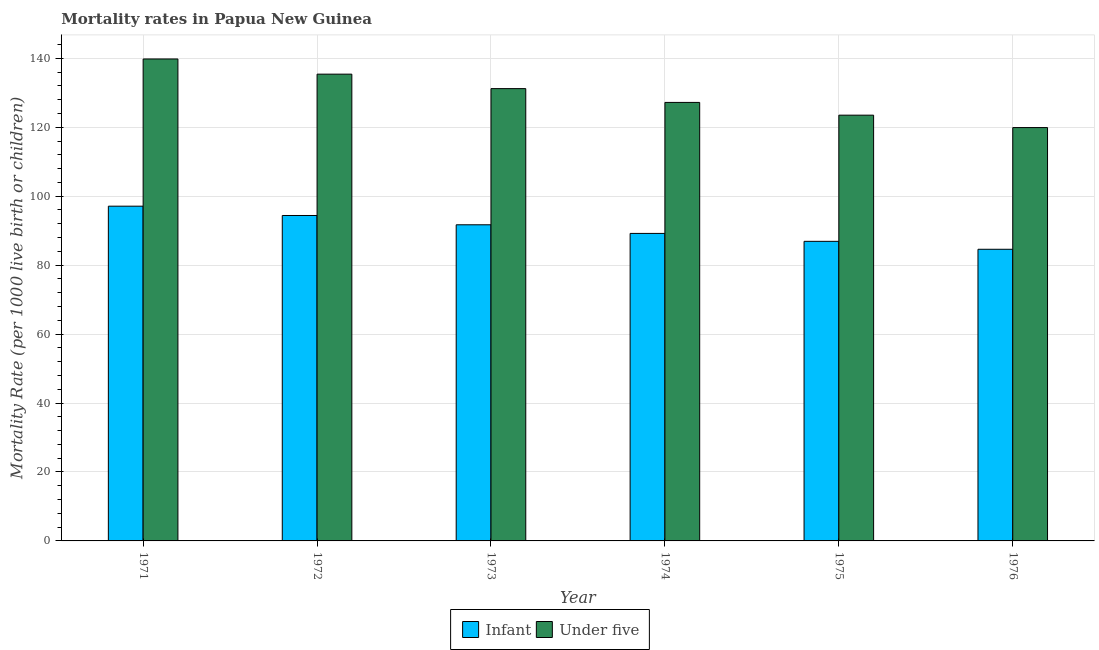How many different coloured bars are there?
Keep it short and to the point. 2. How many groups of bars are there?
Your answer should be compact. 6. What is the label of the 5th group of bars from the left?
Ensure brevity in your answer.  1975. What is the under-5 mortality rate in 1974?
Your response must be concise. 127.2. Across all years, what is the maximum infant mortality rate?
Offer a very short reply. 97.1. Across all years, what is the minimum infant mortality rate?
Make the answer very short. 84.6. In which year was the under-5 mortality rate maximum?
Give a very brief answer. 1971. In which year was the under-5 mortality rate minimum?
Make the answer very short. 1976. What is the total infant mortality rate in the graph?
Your answer should be compact. 543.9. What is the difference between the infant mortality rate in 1971 and that in 1974?
Offer a terse response. 7.9. What is the difference between the under-5 mortality rate in 1974 and the infant mortality rate in 1972?
Ensure brevity in your answer.  -8.2. What is the average infant mortality rate per year?
Provide a short and direct response. 90.65. In how many years, is the infant mortality rate greater than 112?
Make the answer very short. 0. What is the ratio of the infant mortality rate in 1972 to that in 1974?
Your response must be concise. 1.06. What is the difference between the highest and the second highest infant mortality rate?
Offer a very short reply. 2.7. Is the sum of the under-5 mortality rate in 1972 and 1976 greater than the maximum infant mortality rate across all years?
Your answer should be compact. Yes. What does the 2nd bar from the left in 1972 represents?
Offer a very short reply. Under five. What does the 2nd bar from the right in 1973 represents?
Provide a short and direct response. Infant. How many bars are there?
Offer a terse response. 12. Are all the bars in the graph horizontal?
Make the answer very short. No. Are the values on the major ticks of Y-axis written in scientific E-notation?
Ensure brevity in your answer.  No. Does the graph contain grids?
Offer a terse response. Yes. Where does the legend appear in the graph?
Your response must be concise. Bottom center. How many legend labels are there?
Offer a terse response. 2. What is the title of the graph?
Keep it short and to the point. Mortality rates in Papua New Guinea. What is the label or title of the X-axis?
Provide a succinct answer. Year. What is the label or title of the Y-axis?
Provide a succinct answer. Mortality Rate (per 1000 live birth or children). What is the Mortality Rate (per 1000 live birth or children) of Infant in 1971?
Provide a short and direct response. 97.1. What is the Mortality Rate (per 1000 live birth or children) in Under five in 1971?
Ensure brevity in your answer.  139.8. What is the Mortality Rate (per 1000 live birth or children) in Infant in 1972?
Provide a succinct answer. 94.4. What is the Mortality Rate (per 1000 live birth or children) in Under five in 1972?
Ensure brevity in your answer.  135.4. What is the Mortality Rate (per 1000 live birth or children) in Infant in 1973?
Offer a very short reply. 91.7. What is the Mortality Rate (per 1000 live birth or children) in Under five in 1973?
Your answer should be compact. 131.2. What is the Mortality Rate (per 1000 live birth or children) in Infant in 1974?
Offer a very short reply. 89.2. What is the Mortality Rate (per 1000 live birth or children) in Under five in 1974?
Offer a terse response. 127.2. What is the Mortality Rate (per 1000 live birth or children) of Infant in 1975?
Your answer should be very brief. 86.9. What is the Mortality Rate (per 1000 live birth or children) of Under five in 1975?
Provide a succinct answer. 123.5. What is the Mortality Rate (per 1000 live birth or children) in Infant in 1976?
Your answer should be very brief. 84.6. What is the Mortality Rate (per 1000 live birth or children) of Under five in 1976?
Your response must be concise. 119.9. Across all years, what is the maximum Mortality Rate (per 1000 live birth or children) of Infant?
Make the answer very short. 97.1. Across all years, what is the maximum Mortality Rate (per 1000 live birth or children) in Under five?
Ensure brevity in your answer.  139.8. Across all years, what is the minimum Mortality Rate (per 1000 live birth or children) in Infant?
Offer a very short reply. 84.6. Across all years, what is the minimum Mortality Rate (per 1000 live birth or children) of Under five?
Ensure brevity in your answer.  119.9. What is the total Mortality Rate (per 1000 live birth or children) of Infant in the graph?
Your response must be concise. 543.9. What is the total Mortality Rate (per 1000 live birth or children) of Under five in the graph?
Your response must be concise. 777. What is the difference between the Mortality Rate (per 1000 live birth or children) in Under five in 1971 and that in 1972?
Provide a short and direct response. 4.4. What is the difference between the Mortality Rate (per 1000 live birth or children) of Under five in 1971 and that in 1973?
Ensure brevity in your answer.  8.6. What is the difference between the Mortality Rate (per 1000 live birth or children) in Infant in 1971 and that in 1974?
Give a very brief answer. 7.9. What is the difference between the Mortality Rate (per 1000 live birth or children) of Under five in 1971 and that in 1974?
Provide a succinct answer. 12.6. What is the difference between the Mortality Rate (per 1000 live birth or children) in Under five in 1971 and that in 1975?
Keep it short and to the point. 16.3. What is the difference between the Mortality Rate (per 1000 live birth or children) in Infant in 1971 and that in 1976?
Give a very brief answer. 12.5. What is the difference between the Mortality Rate (per 1000 live birth or children) in Under five in 1971 and that in 1976?
Your answer should be compact. 19.9. What is the difference between the Mortality Rate (per 1000 live birth or children) of Infant in 1972 and that in 1973?
Provide a short and direct response. 2.7. What is the difference between the Mortality Rate (per 1000 live birth or children) in Under five in 1972 and that in 1975?
Your answer should be very brief. 11.9. What is the difference between the Mortality Rate (per 1000 live birth or children) in Under five in 1972 and that in 1976?
Provide a succinct answer. 15.5. What is the difference between the Mortality Rate (per 1000 live birth or children) in Infant in 1973 and that in 1974?
Ensure brevity in your answer.  2.5. What is the difference between the Mortality Rate (per 1000 live birth or children) of Under five in 1973 and that in 1974?
Offer a terse response. 4. What is the difference between the Mortality Rate (per 1000 live birth or children) in Infant in 1973 and that in 1976?
Provide a succinct answer. 7.1. What is the difference between the Mortality Rate (per 1000 live birth or children) of Under five in 1973 and that in 1976?
Your answer should be very brief. 11.3. What is the difference between the Mortality Rate (per 1000 live birth or children) in Under five in 1974 and that in 1975?
Your response must be concise. 3.7. What is the difference between the Mortality Rate (per 1000 live birth or children) of Under five in 1974 and that in 1976?
Ensure brevity in your answer.  7.3. What is the difference between the Mortality Rate (per 1000 live birth or children) in Under five in 1975 and that in 1976?
Provide a short and direct response. 3.6. What is the difference between the Mortality Rate (per 1000 live birth or children) of Infant in 1971 and the Mortality Rate (per 1000 live birth or children) of Under five in 1972?
Your answer should be very brief. -38.3. What is the difference between the Mortality Rate (per 1000 live birth or children) of Infant in 1971 and the Mortality Rate (per 1000 live birth or children) of Under five in 1973?
Your answer should be very brief. -34.1. What is the difference between the Mortality Rate (per 1000 live birth or children) in Infant in 1971 and the Mortality Rate (per 1000 live birth or children) in Under five in 1974?
Offer a very short reply. -30.1. What is the difference between the Mortality Rate (per 1000 live birth or children) in Infant in 1971 and the Mortality Rate (per 1000 live birth or children) in Under five in 1975?
Your answer should be very brief. -26.4. What is the difference between the Mortality Rate (per 1000 live birth or children) of Infant in 1971 and the Mortality Rate (per 1000 live birth or children) of Under five in 1976?
Make the answer very short. -22.8. What is the difference between the Mortality Rate (per 1000 live birth or children) in Infant in 1972 and the Mortality Rate (per 1000 live birth or children) in Under five in 1973?
Make the answer very short. -36.8. What is the difference between the Mortality Rate (per 1000 live birth or children) of Infant in 1972 and the Mortality Rate (per 1000 live birth or children) of Under five in 1974?
Your answer should be compact. -32.8. What is the difference between the Mortality Rate (per 1000 live birth or children) in Infant in 1972 and the Mortality Rate (per 1000 live birth or children) in Under five in 1975?
Your answer should be compact. -29.1. What is the difference between the Mortality Rate (per 1000 live birth or children) in Infant in 1972 and the Mortality Rate (per 1000 live birth or children) in Under five in 1976?
Your answer should be very brief. -25.5. What is the difference between the Mortality Rate (per 1000 live birth or children) in Infant in 1973 and the Mortality Rate (per 1000 live birth or children) in Under five in 1974?
Keep it short and to the point. -35.5. What is the difference between the Mortality Rate (per 1000 live birth or children) of Infant in 1973 and the Mortality Rate (per 1000 live birth or children) of Under five in 1975?
Give a very brief answer. -31.8. What is the difference between the Mortality Rate (per 1000 live birth or children) of Infant in 1973 and the Mortality Rate (per 1000 live birth or children) of Under five in 1976?
Your answer should be compact. -28.2. What is the difference between the Mortality Rate (per 1000 live birth or children) of Infant in 1974 and the Mortality Rate (per 1000 live birth or children) of Under five in 1975?
Provide a succinct answer. -34.3. What is the difference between the Mortality Rate (per 1000 live birth or children) in Infant in 1974 and the Mortality Rate (per 1000 live birth or children) in Under five in 1976?
Make the answer very short. -30.7. What is the difference between the Mortality Rate (per 1000 live birth or children) of Infant in 1975 and the Mortality Rate (per 1000 live birth or children) of Under five in 1976?
Offer a very short reply. -33. What is the average Mortality Rate (per 1000 live birth or children) in Infant per year?
Keep it short and to the point. 90.65. What is the average Mortality Rate (per 1000 live birth or children) in Under five per year?
Provide a succinct answer. 129.5. In the year 1971, what is the difference between the Mortality Rate (per 1000 live birth or children) in Infant and Mortality Rate (per 1000 live birth or children) in Under five?
Give a very brief answer. -42.7. In the year 1972, what is the difference between the Mortality Rate (per 1000 live birth or children) in Infant and Mortality Rate (per 1000 live birth or children) in Under five?
Your answer should be compact. -41. In the year 1973, what is the difference between the Mortality Rate (per 1000 live birth or children) in Infant and Mortality Rate (per 1000 live birth or children) in Under five?
Provide a short and direct response. -39.5. In the year 1974, what is the difference between the Mortality Rate (per 1000 live birth or children) in Infant and Mortality Rate (per 1000 live birth or children) in Under five?
Offer a very short reply. -38. In the year 1975, what is the difference between the Mortality Rate (per 1000 live birth or children) in Infant and Mortality Rate (per 1000 live birth or children) in Under five?
Provide a short and direct response. -36.6. In the year 1976, what is the difference between the Mortality Rate (per 1000 live birth or children) of Infant and Mortality Rate (per 1000 live birth or children) of Under five?
Keep it short and to the point. -35.3. What is the ratio of the Mortality Rate (per 1000 live birth or children) of Infant in 1971 to that in 1972?
Your response must be concise. 1.03. What is the ratio of the Mortality Rate (per 1000 live birth or children) in Under five in 1971 to that in 1972?
Offer a terse response. 1.03. What is the ratio of the Mortality Rate (per 1000 live birth or children) of Infant in 1971 to that in 1973?
Offer a very short reply. 1.06. What is the ratio of the Mortality Rate (per 1000 live birth or children) in Under five in 1971 to that in 1973?
Provide a short and direct response. 1.07. What is the ratio of the Mortality Rate (per 1000 live birth or children) in Infant in 1971 to that in 1974?
Ensure brevity in your answer.  1.09. What is the ratio of the Mortality Rate (per 1000 live birth or children) in Under five in 1971 to that in 1974?
Keep it short and to the point. 1.1. What is the ratio of the Mortality Rate (per 1000 live birth or children) of Infant in 1971 to that in 1975?
Provide a short and direct response. 1.12. What is the ratio of the Mortality Rate (per 1000 live birth or children) of Under five in 1971 to that in 1975?
Ensure brevity in your answer.  1.13. What is the ratio of the Mortality Rate (per 1000 live birth or children) of Infant in 1971 to that in 1976?
Keep it short and to the point. 1.15. What is the ratio of the Mortality Rate (per 1000 live birth or children) in Under five in 1971 to that in 1976?
Make the answer very short. 1.17. What is the ratio of the Mortality Rate (per 1000 live birth or children) in Infant in 1972 to that in 1973?
Keep it short and to the point. 1.03. What is the ratio of the Mortality Rate (per 1000 live birth or children) of Under five in 1972 to that in 1973?
Give a very brief answer. 1.03. What is the ratio of the Mortality Rate (per 1000 live birth or children) in Infant in 1972 to that in 1974?
Provide a succinct answer. 1.06. What is the ratio of the Mortality Rate (per 1000 live birth or children) in Under five in 1972 to that in 1974?
Provide a succinct answer. 1.06. What is the ratio of the Mortality Rate (per 1000 live birth or children) in Infant in 1972 to that in 1975?
Keep it short and to the point. 1.09. What is the ratio of the Mortality Rate (per 1000 live birth or children) in Under five in 1972 to that in 1975?
Make the answer very short. 1.1. What is the ratio of the Mortality Rate (per 1000 live birth or children) of Infant in 1972 to that in 1976?
Provide a short and direct response. 1.12. What is the ratio of the Mortality Rate (per 1000 live birth or children) of Under five in 1972 to that in 1976?
Your answer should be compact. 1.13. What is the ratio of the Mortality Rate (per 1000 live birth or children) of Infant in 1973 to that in 1974?
Your answer should be very brief. 1.03. What is the ratio of the Mortality Rate (per 1000 live birth or children) in Under five in 1973 to that in 1974?
Your response must be concise. 1.03. What is the ratio of the Mortality Rate (per 1000 live birth or children) in Infant in 1973 to that in 1975?
Your answer should be compact. 1.06. What is the ratio of the Mortality Rate (per 1000 live birth or children) in Under five in 1973 to that in 1975?
Your response must be concise. 1.06. What is the ratio of the Mortality Rate (per 1000 live birth or children) of Infant in 1973 to that in 1976?
Your answer should be very brief. 1.08. What is the ratio of the Mortality Rate (per 1000 live birth or children) of Under five in 1973 to that in 1976?
Keep it short and to the point. 1.09. What is the ratio of the Mortality Rate (per 1000 live birth or children) of Infant in 1974 to that in 1975?
Offer a very short reply. 1.03. What is the ratio of the Mortality Rate (per 1000 live birth or children) of Infant in 1974 to that in 1976?
Give a very brief answer. 1.05. What is the ratio of the Mortality Rate (per 1000 live birth or children) of Under five in 1974 to that in 1976?
Provide a short and direct response. 1.06. What is the ratio of the Mortality Rate (per 1000 live birth or children) of Infant in 1975 to that in 1976?
Offer a very short reply. 1.03. 